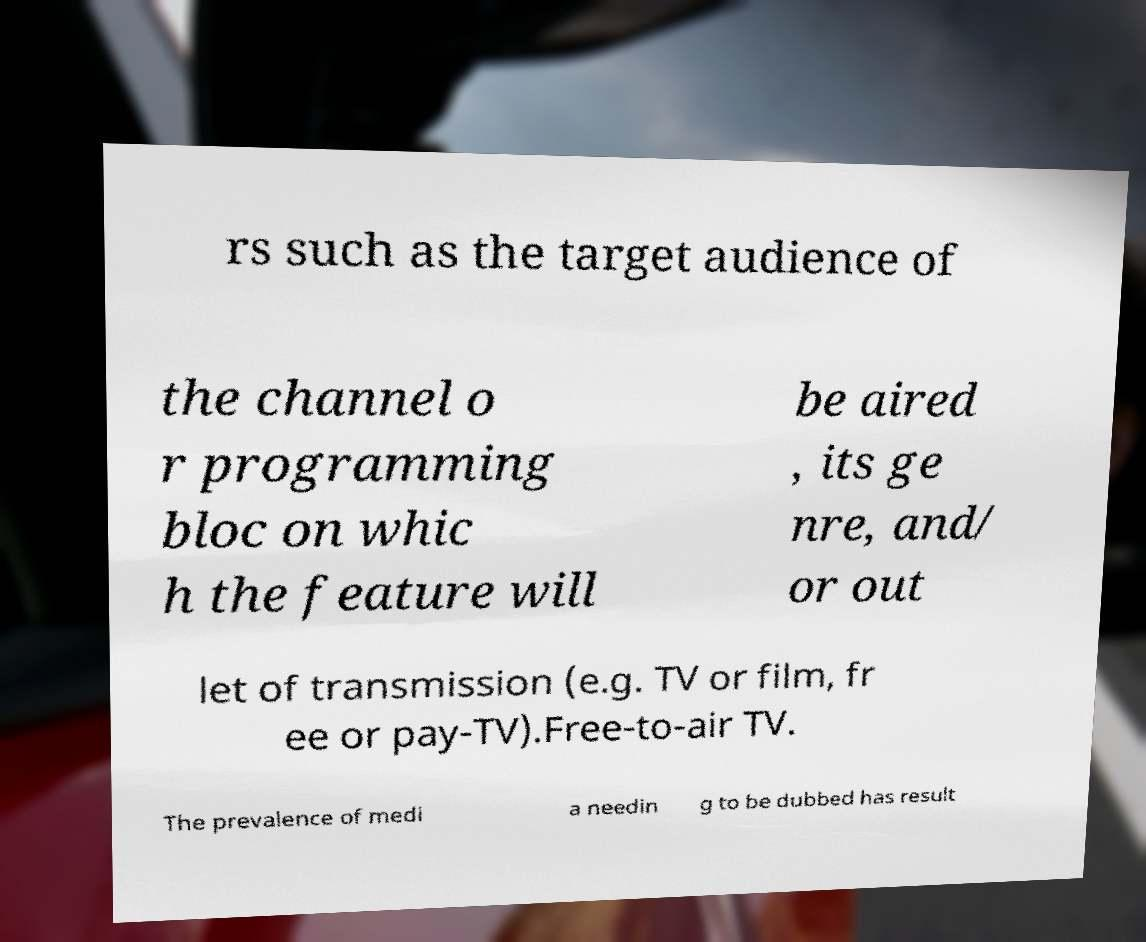Can you read and provide the text displayed in the image?This photo seems to have some interesting text. Can you extract and type it out for me? rs such as the target audience of the channel o r programming bloc on whic h the feature will be aired , its ge nre, and/ or out let of transmission (e.g. TV or film, fr ee or pay-TV).Free-to-air TV. The prevalence of medi a needin g to be dubbed has result 